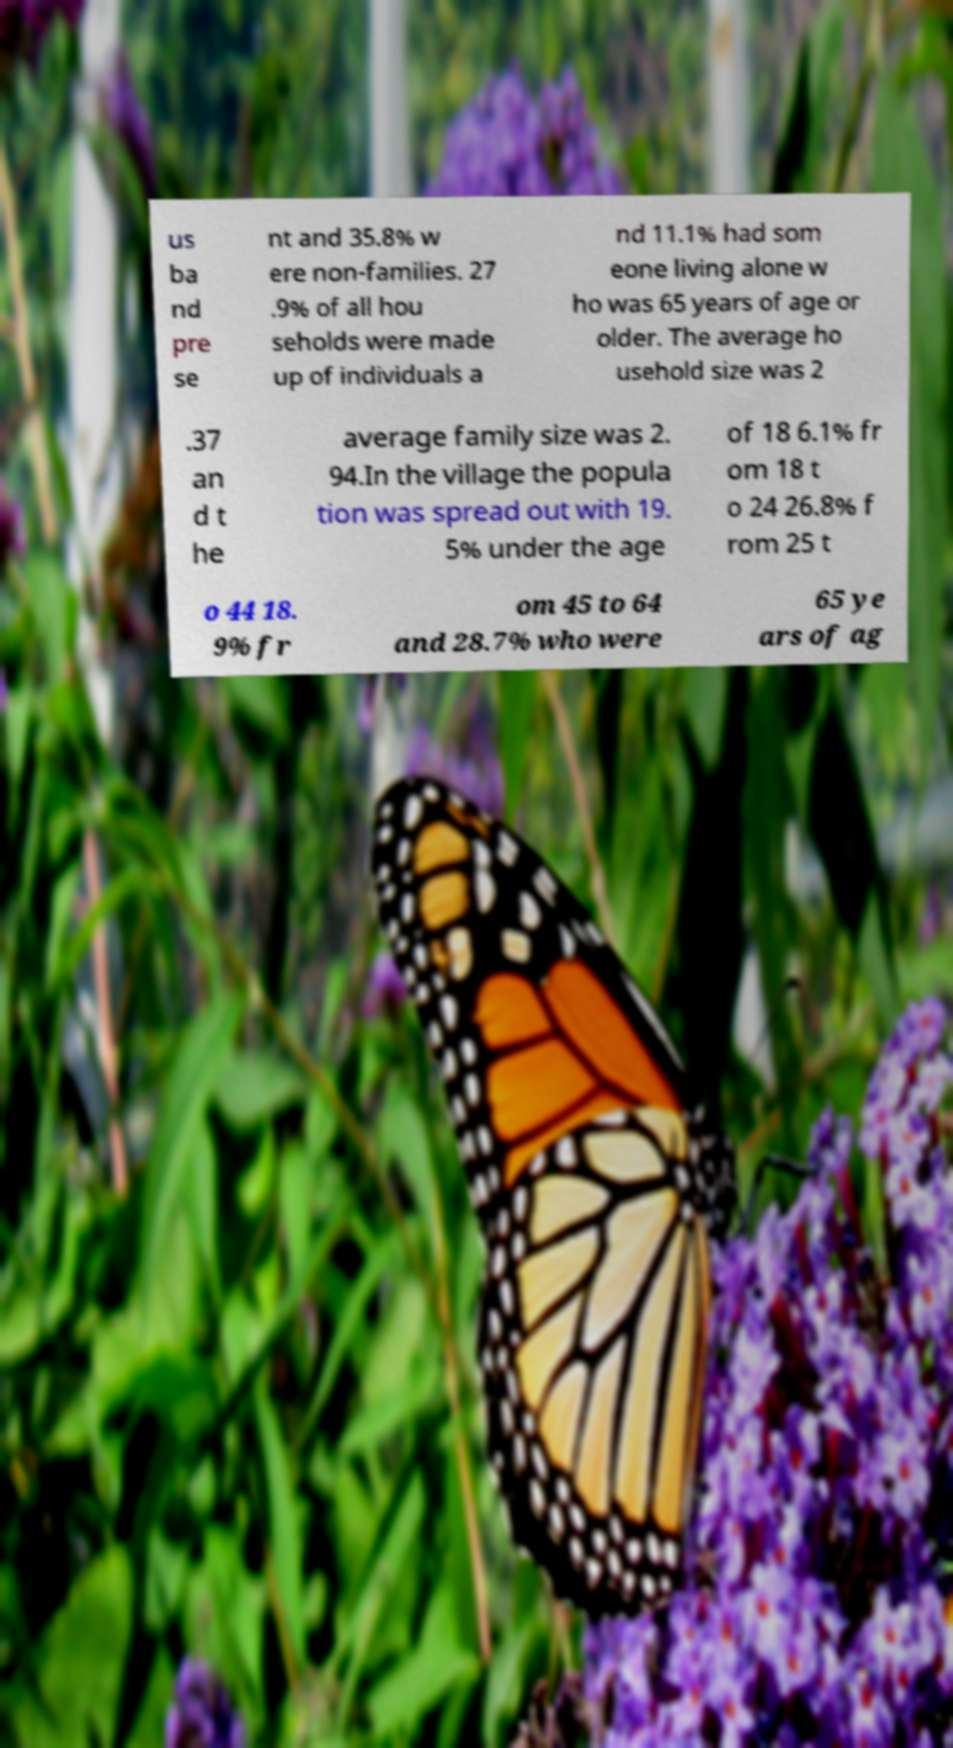Please identify and transcribe the text found in this image. us ba nd pre se nt and 35.8% w ere non-families. 27 .9% of all hou seholds were made up of individuals a nd 11.1% had som eone living alone w ho was 65 years of age or older. The average ho usehold size was 2 .37 an d t he average family size was 2. 94.In the village the popula tion was spread out with 19. 5% under the age of 18 6.1% fr om 18 t o 24 26.8% f rom 25 t o 44 18. 9% fr om 45 to 64 and 28.7% who were 65 ye ars of ag 